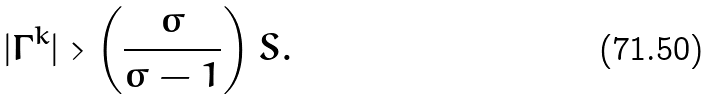<formula> <loc_0><loc_0><loc_500><loc_500>| \Gamma ^ { k } | > \left ( \frac { \sigma } { \sigma - 1 } \right ) S .</formula> 